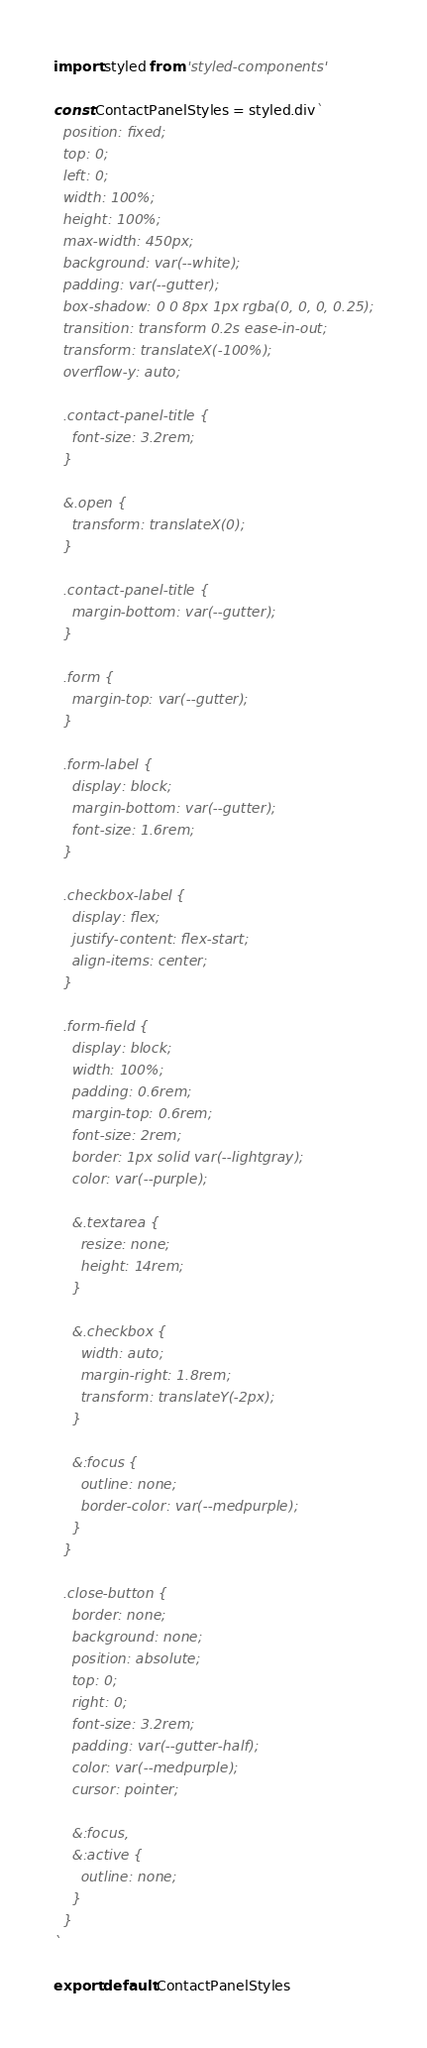Convert code to text. <code><loc_0><loc_0><loc_500><loc_500><_JavaScript_>import styled from 'styled-components'

const ContactPanelStyles = styled.div`
  position: fixed;
  top: 0;
  left: 0;
  width: 100%;
  height: 100%;
  max-width: 450px;
  background: var(--white);
  padding: var(--gutter);
  box-shadow: 0 0 8px 1px rgba(0, 0, 0, 0.25);
  transition: transform 0.2s ease-in-out;
  transform: translateX(-100%);
  overflow-y: auto;

  .contact-panel-title {
    font-size: 3.2rem;
  }

  &.open {
    transform: translateX(0);
  }

  .contact-panel-title {
    margin-bottom: var(--gutter);
  }

  .form {
    margin-top: var(--gutter);
  }

  .form-label {
    display: block;
    margin-bottom: var(--gutter);
    font-size: 1.6rem;
  }

  .checkbox-label {
    display: flex;
    justify-content: flex-start;
    align-items: center;
  }

  .form-field {
    display: block;
    width: 100%;
    padding: 0.6rem;
    margin-top: 0.6rem;
    font-size: 2rem;
    border: 1px solid var(--lightgray);
    color: var(--purple);

    &.textarea {
      resize: none;
      height: 14rem;
    }

    &.checkbox {
      width: auto;
      margin-right: 1.8rem;
      transform: translateY(-2px);
    }

    &:focus {
      outline: none;
      border-color: var(--medpurple);
    }
  }

  .close-button {
    border: none;
    background: none;
    position: absolute;
    top: 0;
    right: 0;
    font-size: 3.2rem;
    padding: var(--gutter-half);
    color: var(--medpurple);
    cursor: pointer;

    &:focus,
    &:active {
      outline: none;
    }
  }
`

export default ContactPanelStyles
</code> 